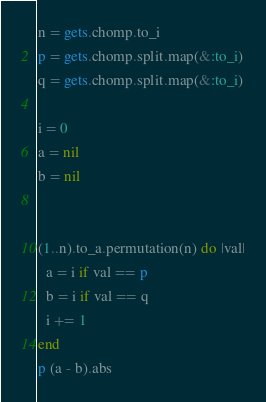<code> <loc_0><loc_0><loc_500><loc_500><_Ruby_>n = gets.chomp.to_i
p = gets.chomp.split.map(&:to_i)
q = gets.chomp.split.map(&:to_i)

i = 0
a = nil
b = nil


(1..n).to_a.permutation(n) do |val|
  a = i if val == p
  b = i if val == q
  i += 1
end
p (a - b).abs</code> 